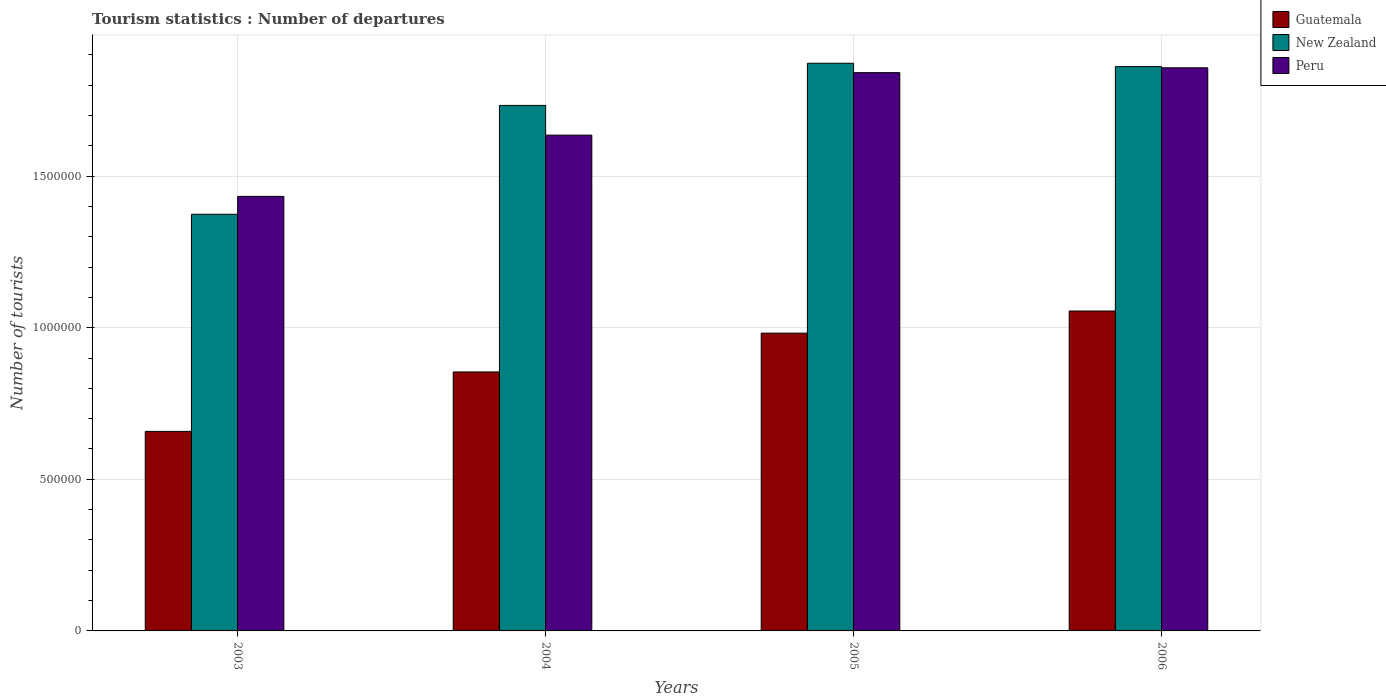How many groups of bars are there?
Provide a succinct answer. 4. Are the number of bars on each tick of the X-axis equal?
Your answer should be very brief. Yes. How many bars are there on the 1st tick from the right?
Give a very brief answer. 3. What is the number of tourist departures in New Zealand in 2005?
Your response must be concise. 1.87e+06. Across all years, what is the maximum number of tourist departures in New Zealand?
Your answer should be very brief. 1.87e+06. Across all years, what is the minimum number of tourist departures in Peru?
Offer a very short reply. 1.43e+06. In which year was the number of tourist departures in New Zealand maximum?
Give a very brief answer. 2005. What is the total number of tourist departures in New Zealand in the graph?
Ensure brevity in your answer.  6.84e+06. What is the difference between the number of tourist departures in New Zealand in 2003 and that in 2004?
Keep it short and to the point. -3.59e+05. What is the difference between the number of tourist departures in Guatemala in 2003 and the number of tourist departures in New Zealand in 2004?
Your answer should be compact. -1.08e+06. What is the average number of tourist departures in Peru per year?
Ensure brevity in your answer.  1.69e+06. In the year 2005, what is the difference between the number of tourist departures in Peru and number of tourist departures in New Zealand?
Offer a terse response. -3.10e+04. In how many years, is the number of tourist departures in New Zealand greater than 900000?
Provide a short and direct response. 4. What is the ratio of the number of tourist departures in Guatemala in 2004 to that in 2005?
Your answer should be compact. 0.87. Is the number of tourist departures in Guatemala in 2003 less than that in 2005?
Give a very brief answer. Yes. What is the difference between the highest and the second highest number of tourist departures in New Zealand?
Make the answer very short. 1.10e+04. What is the difference between the highest and the lowest number of tourist departures in New Zealand?
Provide a succinct answer. 4.98e+05. What does the 3rd bar from the left in 2006 represents?
Provide a short and direct response. Peru. What does the 3rd bar from the right in 2003 represents?
Your answer should be compact. Guatemala. Is it the case that in every year, the sum of the number of tourist departures in Peru and number of tourist departures in New Zealand is greater than the number of tourist departures in Guatemala?
Offer a terse response. Yes. How many bars are there?
Offer a very short reply. 12. How many years are there in the graph?
Provide a short and direct response. 4. What is the difference between two consecutive major ticks on the Y-axis?
Ensure brevity in your answer.  5.00e+05. Does the graph contain any zero values?
Offer a terse response. No. Does the graph contain grids?
Provide a succinct answer. Yes. Where does the legend appear in the graph?
Give a very brief answer. Top right. How many legend labels are there?
Keep it short and to the point. 3. What is the title of the graph?
Your answer should be compact. Tourism statistics : Number of departures. Does "Tunisia" appear as one of the legend labels in the graph?
Offer a very short reply. No. What is the label or title of the X-axis?
Your answer should be very brief. Years. What is the label or title of the Y-axis?
Make the answer very short. Number of tourists. What is the Number of tourists in Guatemala in 2003?
Offer a very short reply. 6.58e+05. What is the Number of tourists of New Zealand in 2003?
Provide a short and direct response. 1.37e+06. What is the Number of tourists of Peru in 2003?
Give a very brief answer. 1.43e+06. What is the Number of tourists in Guatemala in 2004?
Your response must be concise. 8.54e+05. What is the Number of tourists in New Zealand in 2004?
Keep it short and to the point. 1.73e+06. What is the Number of tourists in Peru in 2004?
Provide a short and direct response. 1.64e+06. What is the Number of tourists in Guatemala in 2005?
Offer a very short reply. 9.82e+05. What is the Number of tourists in New Zealand in 2005?
Give a very brief answer. 1.87e+06. What is the Number of tourists in Peru in 2005?
Offer a very short reply. 1.84e+06. What is the Number of tourists in Guatemala in 2006?
Provide a short and direct response. 1.06e+06. What is the Number of tourists in New Zealand in 2006?
Keep it short and to the point. 1.86e+06. What is the Number of tourists in Peru in 2006?
Make the answer very short. 1.86e+06. Across all years, what is the maximum Number of tourists of Guatemala?
Keep it short and to the point. 1.06e+06. Across all years, what is the maximum Number of tourists of New Zealand?
Keep it short and to the point. 1.87e+06. Across all years, what is the maximum Number of tourists in Peru?
Offer a terse response. 1.86e+06. Across all years, what is the minimum Number of tourists in Guatemala?
Your answer should be very brief. 6.58e+05. Across all years, what is the minimum Number of tourists of New Zealand?
Provide a short and direct response. 1.37e+06. Across all years, what is the minimum Number of tourists in Peru?
Keep it short and to the point. 1.43e+06. What is the total Number of tourists of Guatemala in the graph?
Your answer should be very brief. 3.55e+06. What is the total Number of tourists of New Zealand in the graph?
Offer a very short reply. 6.84e+06. What is the total Number of tourists in Peru in the graph?
Your answer should be compact. 6.77e+06. What is the difference between the Number of tourists of Guatemala in 2003 and that in 2004?
Offer a very short reply. -1.96e+05. What is the difference between the Number of tourists of New Zealand in 2003 and that in 2004?
Offer a terse response. -3.59e+05. What is the difference between the Number of tourists of Peru in 2003 and that in 2004?
Provide a short and direct response. -2.02e+05. What is the difference between the Number of tourists in Guatemala in 2003 and that in 2005?
Your answer should be compact. -3.24e+05. What is the difference between the Number of tourists of New Zealand in 2003 and that in 2005?
Offer a very short reply. -4.98e+05. What is the difference between the Number of tourists of Peru in 2003 and that in 2005?
Provide a succinct answer. -4.08e+05. What is the difference between the Number of tourists in Guatemala in 2003 and that in 2006?
Provide a succinct answer. -3.97e+05. What is the difference between the Number of tourists in New Zealand in 2003 and that in 2006?
Keep it short and to the point. -4.87e+05. What is the difference between the Number of tourists in Peru in 2003 and that in 2006?
Your answer should be compact. -4.24e+05. What is the difference between the Number of tourists of Guatemala in 2004 and that in 2005?
Keep it short and to the point. -1.28e+05. What is the difference between the Number of tourists in New Zealand in 2004 and that in 2005?
Offer a very short reply. -1.39e+05. What is the difference between the Number of tourists in Peru in 2004 and that in 2005?
Your answer should be very brief. -2.06e+05. What is the difference between the Number of tourists in Guatemala in 2004 and that in 2006?
Ensure brevity in your answer.  -2.01e+05. What is the difference between the Number of tourists of New Zealand in 2004 and that in 2006?
Offer a very short reply. -1.28e+05. What is the difference between the Number of tourists in Peru in 2004 and that in 2006?
Provide a succinct answer. -2.22e+05. What is the difference between the Number of tourists in Guatemala in 2005 and that in 2006?
Give a very brief answer. -7.30e+04. What is the difference between the Number of tourists of New Zealand in 2005 and that in 2006?
Your response must be concise. 1.10e+04. What is the difference between the Number of tourists in Peru in 2005 and that in 2006?
Provide a succinct answer. -1.60e+04. What is the difference between the Number of tourists of Guatemala in 2003 and the Number of tourists of New Zealand in 2004?
Offer a terse response. -1.08e+06. What is the difference between the Number of tourists in Guatemala in 2003 and the Number of tourists in Peru in 2004?
Your response must be concise. -9.77e+05. What is the difference between the Number of tourists in New Zealand in 2003 and the Number of tourists in Peru in 2004?
Give a very brief answer. -2.61e+05. What is the difference between the Number of tourists of Guatemala in 2003 and the Number of tourists of New Zealand in 2005?
Keep it short and to the point. -1.21e+06. What is the difference between the Number of tourists of Guatemala in 2003 and the Number of tourists of Peru in 2005?
Make the answer very short. -1.18e+06. What is the difference between the Number of tourists of New Zealand in 2003 and the Number of tourists of Peru in 2005?
Provide a short and direct response. -4.67e+05. What is the difference between the Number of tourists of Guatemala in 2003 and the Number of tourists of New Zealand in 2006?
Offer a very short reply. -1.20e+06. What is the difference between the Number of tourists in Guatemala in 2003 and the Number of tourists in Peru in 2006?
Keep it short and to the point. -1.20e+06. What is the difference between the Number of tourists in New Zealand in 2003 and the Number of tourists in Peru in 2006?
Ensure brevity in your answer.  -4.83e+05. What is the difference between the Number of tourists in Guatemala in 2004 and the Number of tourists in New Zealand in 2005?
Your response must be concise. -1.02e+06. What is the difference between the Number of tourists of Guatemala in 2004 and the Number of tourists of Peru in 2005?
Keep it short and to the point. -9.87e+05. What is the difference between the Number of tourists of New Zealand in 2004 and the Number of tourists of Peru in 2005?
Keep it short and to the point. -1.08e+05. What is the difference between the Number of tourists in Guatemala in 2004 and the Number of tourists in New Zealand in 2006?
Provide a short and direct response. -1.01e+06. What is the difference between the Number of tourists in Guatemala in 2004 and the Number of tourists in Peru in 2006?
Your response must be concise. -1.00e+06. What is the difference between the Number of tourists in New Zealand in 2004 and the Number of tourists in Peru in 2006?
Your answer should be compact. -1.24e+05. What is the difference between the Number of tourists in Guatemala in 2005 and the Number of tourists in New Zealand in 2006?
Offer a terse response. -8.79e+05. What is the difference between the Number of tourists of Guatemala in 2005 and the Number of tourists of Peru in 2006?
Your answer should be compact. -8.75e+05. What is the difference between the Number of tourists in New Zealand in 2005 and the Number of tourists in Peru in 2006?
Provide a short and direct response. 1.50e+04. What is the average Number of tourists in Guatemala per year?
Provide a short and direct response. 8.87e+05. What is the average Number of tourists of New Zealand per year?
Your response must be concise. 1.71e+06. What is the average Number of tourists in Peru per year?
Keep it short and to the point. 1.69e+06. In the year 2003, what is the difference between the Number of tourists of Guatemala and Number of tourists of New Zealand?
Give a very brief answer. -7.16e+05. In the year 2003, what is the difference between the Number of tourists of Guatemala and Number of tourists of Peru?
Offer a terse response. -7.75e+05. In the year 2003, what is the difference between the Number of tourists of New Zealand and Number of tourists of Peru?
Offer a terse response. -5.90e+04. In the year 2004, what is the difference between the Number of tourists of Guatemala and Number of tourists of New Zealand?
Offer a terse response. -8.79e+05. In the year 2004, what is the difference between the Number of tourists in Guatemala and Number of tourists in Peru?
Offer a very short reply. -7.81e+05. In the year 2004, what is the difference between the Number of tourists in New Zealand and Number of tourists in Peru?
Your answer should be compact. 9.80e+04. In the year 2005, what is the difference between the Number of tourists of Guatemala and Number of tourists of New Zealand?
Provide a succinct answer. -8.90e+05. In the year 2005, what is the difference between the Number of tourists in Guatemala and Number of tourists in Peru?
Offer a very short reply. -8.59e+05. In the year 2005, what is the difference between the Number of tourists of New Zealand and Number of tourists of Peru?
Your answer should be very brief. 3.10e+04. In the year 2006, what is the difference between the Number of tourists of Guatemala and Number of tourists of New Zealand?
Give a very brief answer. -8.06e+05. In the year 2006, what is the difference between the Number of tourists in Guatemala and Number of tourists in Peru?
Offer a terse response. -8.02e+05. In the year 2006, what is the difference between the Number of tourists of New Zealand and Number of tourists of Peru?
Your response must be concise. 4000. What is the ratio of the Number of tourists of Guatemala in 2003 to that in 2004?
Keep it short and to the point. 0.77. What is the ratio of the Number of tourists of New Zealand in 2003 to that in 2004?
Keep it short and to the point. 0.79. What is the ratio of the Number of tourists of Peru in 2003 to that in 2004?
Your answer should be very brief. 0.88. What is the ratio of the Number of tourists in Guatemala in 2003 to that in 2005?
Keep it short and to the point. 0.67. What is the ratio of the Number of tourists in New Zealand in 2003 to that in 2005?
Offer a very short reply. 0.73. What is the ratio of the Number of tourists in Peru in 2003 to that in 2005?
Your answer should be compact. 0.78. What is the ratio of the Number of tourists of Guatemala in 2003 to that in 2006?
Offer a very short reply. 0.62. What is the ratio of the Number of tourists of New Zealand in 2003 to that in 2006?
Ensure brevity in your answer.  0.74. What is the ratio of the Number of tourists of Peru in 2003 to that in 2006?
Offer a very short reply. 0.77. What is the ratio of the Number of tourists in Guatemala in 2004 to that in 2005?
Offer a terse response. 0.87. What is the ratio of the Number of tourists in New Zealand in 2004 to that in 2005?
Your answer should be very brief. 0.93. What is the ratio of the Number of tourists of Peru in 2004 to that in 2005?
Offer a very short reply. 0.89. What is the ratio of the Number of tourists in Guatemala in 2004 to that in 2006?
Your answer should be compact. 0.81. What is the ratio of the Number of tourists in New Zealand in 2004 to that in 2006?
Offer a very short reply. 0.93. What is the ratio of the Number of tourists in Peru in 2004 to that in 2006?
Offer a very short reply. 0.88. What is the ratio of the Number of tourists of Guatemala in 2005 to that in 2006?
Your answer should be compact. 0.93. What is the ratio of the Number of tourists in New Zealand in 2005 to that in 2006?
Provide a succinct answer. 1.01. What is the difference between the highest and the second highest Number of tourists in Guatemala?
Offer a terse response. 7.30e+04. What is the difference between the highest and the second highest Number of tourists of New Zealand?
Keep it short and to the point. 1.10e+04. What is the difference between the highest and the second highest Number of tourists in Peru?
Provide a short and direct response. 1.60e+04. What is the difference between the highest and the lowest Number of tourists of Guatemala?
Your answer should be very brief. 3.97e+05. What is the difference between the highest and the lowest Number of tourists of New Zealand?
Your answer should be compact. 4.98e+05. What is the difference between the highest and the lowest Number of tourists of Peru?
Provide a succinct answer. 4.24e+05. 